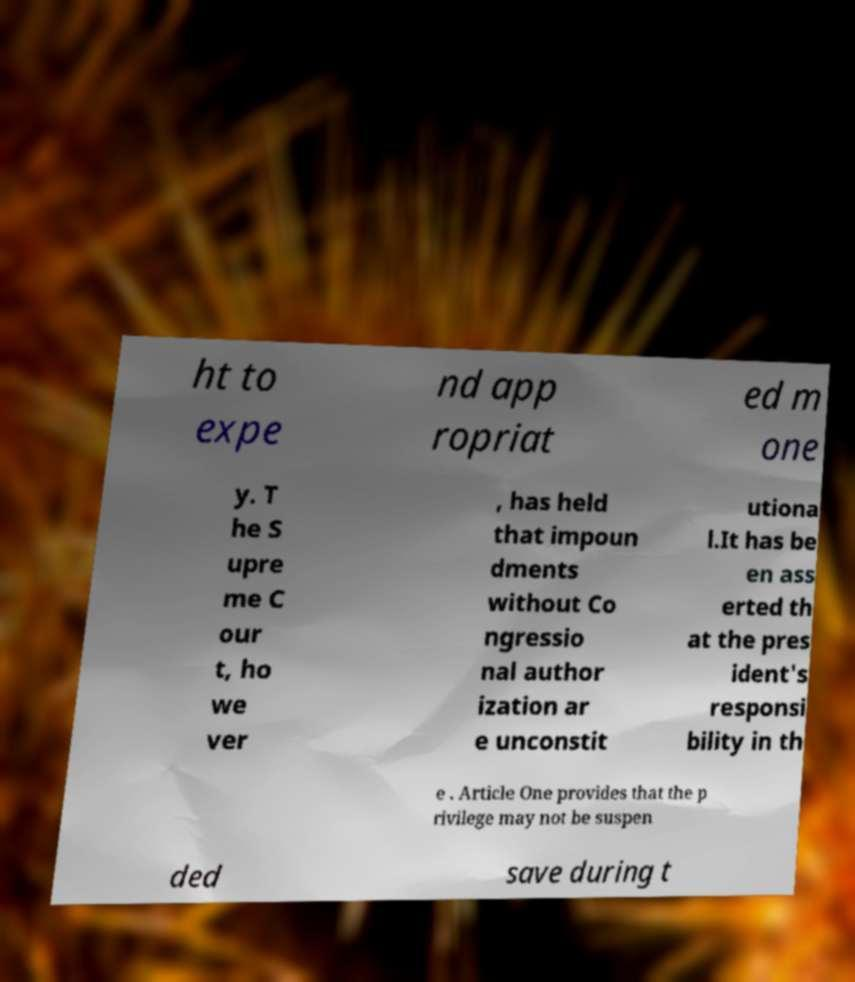Can you read and provide the text displayed in the image?This photo seems to have some interesting text. Can you extract and type it out for me? ht to expe nd app ropriat ed m one y. T he S upre me C our t, ho we ver , has held that impoun dments without Co ngressio nal author ization ar e unconstit utiona l.It has be en ass erted th at the pres ident's responsi bility in th e . Article One provides that the p rivilege may not be suspen ded save during t 